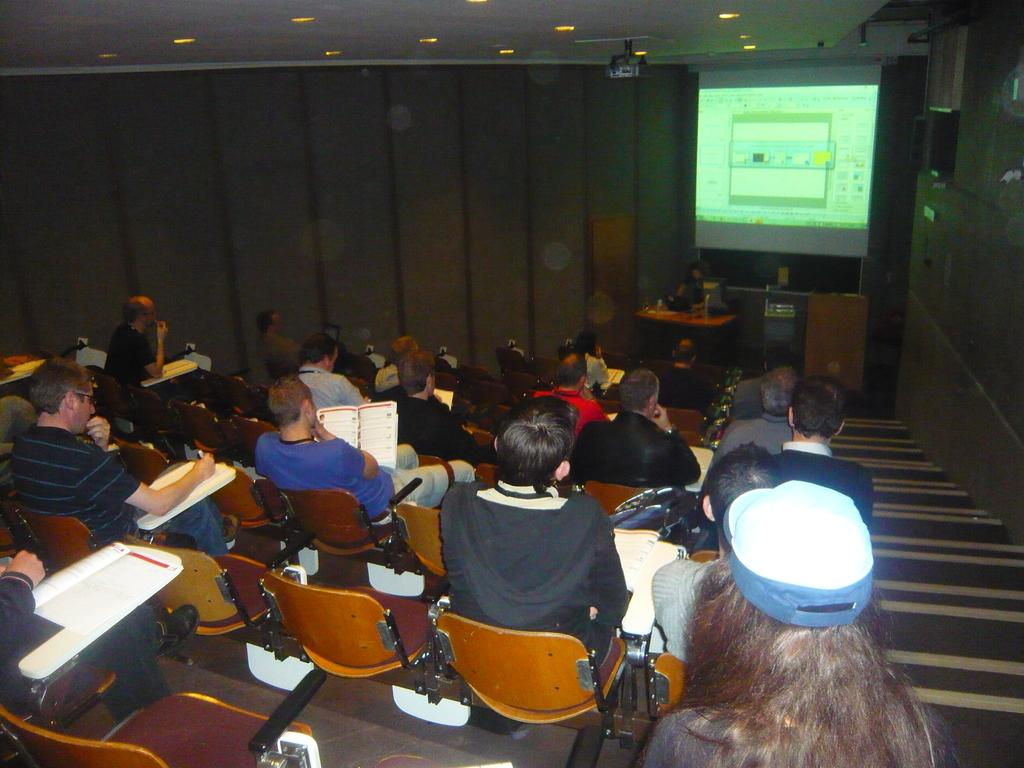What are the people in the image doing? There is a group of persons sitting on chairs in the image. What can be seen on the wall in the image? There is a wall in the image, but no specific details about the wall are mentioned. What is the purpose of the projector screen in the image? The presence of a projector screen suggests that the group of persons might be watching a presentation or movie. What architectural feature is visible in the image? There is a staircase in the image. Can you tell me how many frogs are sitting on the chairs with the group of persons? There are no frogs present in the image; only a group of persons sitting on chairs is visible. 